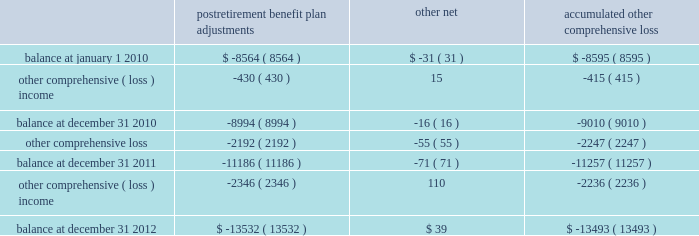Until the hedged transaction is recognized in earnings .
Changes in the fair value of the derivatives that are attributable to the ineffective portion of the hedges , or of derivatives that are not considered to be highly effective hedges , if any , are immediately recognized in earnings .
The aggregate notional amount of our outstanding foreign currency hedges at december 31 , 2012 and 2011 was $ 1.3 billion and $ 1.7 billion .
The aggregate notional amount of our outstanding interest rate swaps at december 31 , 2012 and 2011 was $ 503 million and $ 450 million .
Derivative instruments did not have a material impact on net earnings and comprehensive income during 2012 , 2011 , and 2010 .
Substantially all of our derivatives are designated for hedge accounting .
See note 15 for more information on the fair value measurements related to our derivative instruments .
Stock-based compensation 2013 compensation cost related to all share-based payments including stock options and restricted stock units is measured at the grant date based on the estimated fair value of the award .
We generally recognize the compensation cost ratably over a three-year vesting period .
Income taxes 2013 we periodically assess our tax filing exposures related to periods that are open to examination .
Based on the latest available information , we evaluate our tax positions to determine whether the position will more likely than not be sustained upon examination by the internal revenue service ( irs ) .
If we cannot reach a more-likely-than-not determination , no benefit is recorded .
If we determine that the tax position is more likely than not to be sustained , we record the largest amount of benefit that is more likely than not to be realized when the tax position is settled .
We record interest and penalties related to income taxes as a component of income tax expense on our statements of earnings .
Interest and penalties are not material .
Accumulated other comprehensive loss 2013 changes in the balance of accumulated other comprehensive loss , net of income taxes , consisted of the following ( in millions ) : postretirement benefit plan adjustments other , net accumulated comprehensive .
The postretirement benefit plan adjustments are shown net of tax benefits at december 31 , 2012 , 2011 , and 2010 of $ 7.4 billion , $ 6.1 billion , and $ 4.9 billion .
These tax benefits include amounts recognized on our income tax returns as current deductions and deferred income taxes , which will be recognized on our tax returns in future years .
See note 7 and note 9 for more information on our income taxes and postretirement plans .
Recent accounting pronouncements 2013 effective january 1 , 2012 , we retrospectively adopted new guidance issued by the financial accounting standards board by presenting total comprehensive income and the components of net income and other comprehensive loss in two separate but consecutive statements .
The adoption of this guidance resulted only in a change in how we present other comprehensive loss in our consolidated financial statements and did not have any impact on our results of operations , financial position , or cash flows. .
In 2003 what was the ratio of the notional amount of our outstanding foreign currency hedges to the outstanding interest rate swaps? 
Computations: (1.3 / 503)
Answer: 0.00258. 